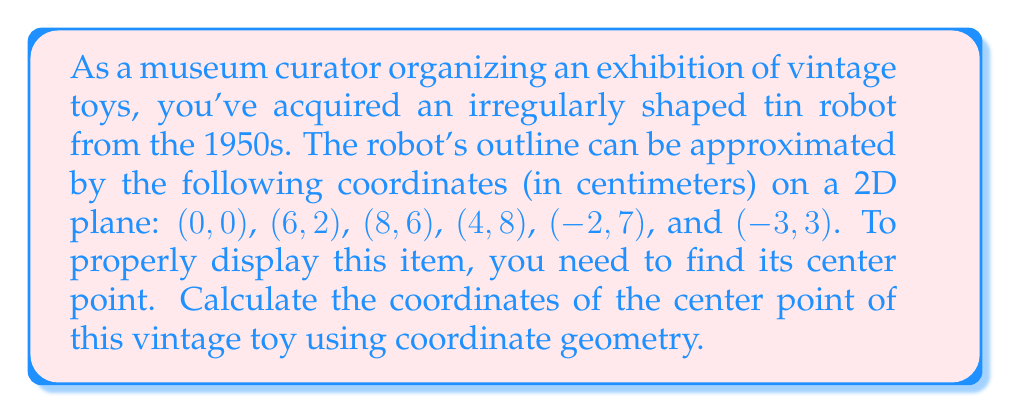Could you help me with this problem? To find the center point of an irregularly shaped object using coordinate geometry, we can use the centroid formula. The centroid is the arithmetic mean position of all the points in the shape.

For a polygon with n vertices, the coordinates of the centroid (Cx, Cy) are given by:

$$ C_x = \frac{1}{n} \sum_{i=1}^n x_i $$
$$ C_y = \frac{1}{n} \sum_{i=1}^n y_i $$

Where $(x_i, y_i)$ are the coordinates of each vertex.

Let's calculate the centroid for our vintage robot:

1. List all x-coordinates: 0, 6, 8, 4, -2, -3
2. List all y-coordinates: 0, 2, 6, 8, 7, 3

3. Calculate Cx:
   $$ C_x = \frac{1}{6} (0 + 6 + 8 + 4 + (-2) + (-3)) = \frac{13}{6} \approx 2.17 $$

4. Calculate Cy:
   $$ C_y = \frac{1}{6} (0 + 2 + 6 + 8 + 7 + 3) = \frac{26}{6} \approx 4.33 $$

Therefore, the center point (centroid) of the vintage toy robot is approximately (2.17, 4.33) in centimeters.

[asy]
unitsize(1cm);
draw((0,0)--(6,2)--(8,6)--(4,8)--(-2,7)--(-3,3)--cycle);
dot((2.17,4.33),red);
label("Center (2.17, 4.33)", (2.17,4.33), E, red);
label("(0,0)", (0,0), SW);
label("(6,2)", (6,2), SE);
label("(8,6)", (8,6), E);
label("(4,8)", (4,8), N);
label("(-2,7)", (-2,7), NW);
label("(-3,3)", (-3,3), W);
[/asy]
Answer: The center point (centroid) of the vintage toy robot is approximately (2.17, 4.33) cm. 